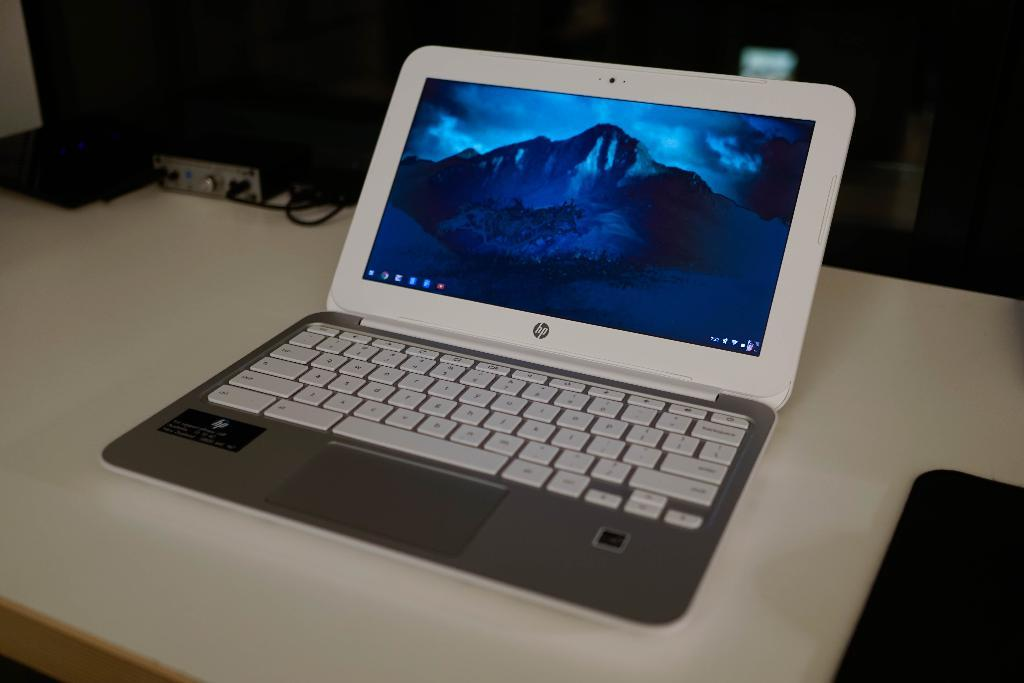<image>
Write a terse but informative summary of the picture. An hp brand laptop is open and shows a desktop background of a mountain. 